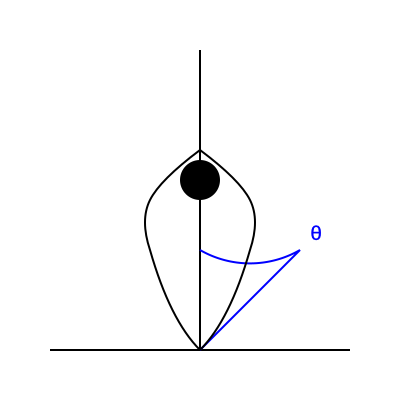In boxing, the optimal defensive stance angle (θ) is crucial for maximizing counter-punching opportunities while minimizing vulnerability. Given that the optimal angle is determined by the equation $\cos \theta = \frac{R}{2L}$, where $R$ is the boxer's reach and $L$ is the distance to the opponent, calculate the optimal angle for a boxer with a reach of 72 inches facing an opponent 48 inches away. Round your answer to the nearest degree. To solve this problem, we'll follow these steps:

1) We are given the equation: $\cos \theta = \frac{R}{2L}$

2) We know:
   $R$ (reach) = 72 inches
   $L$ (distance to opponent) = 48 inches

3) Let's substitute these values into the equation:

   $\cos \theta = \frac{72}{2(48)} = \frac{72}{96} = \frac{3}{4} = 0.75$

4) Now we need to find θ. We can do this by taking the inverse cosine (arccos) of both sides:

   $\theta = \arccos(0.75)$

5) Using a calculator or mathematical software:

   $\theta \approx 0.7227$ radians

6) Convert radians to degrees:

   $\theta \approx 0.7227 \times \frac{180}{\pi} \approx 41.4096$ degrees

7) Rounding to the nearest degree:

   $\theta \approx 41$ degrees

Therefore, the optimal defensive stance angle for the boxer in this situation is approximately 41 degrees.
Answer: 41 degrees 